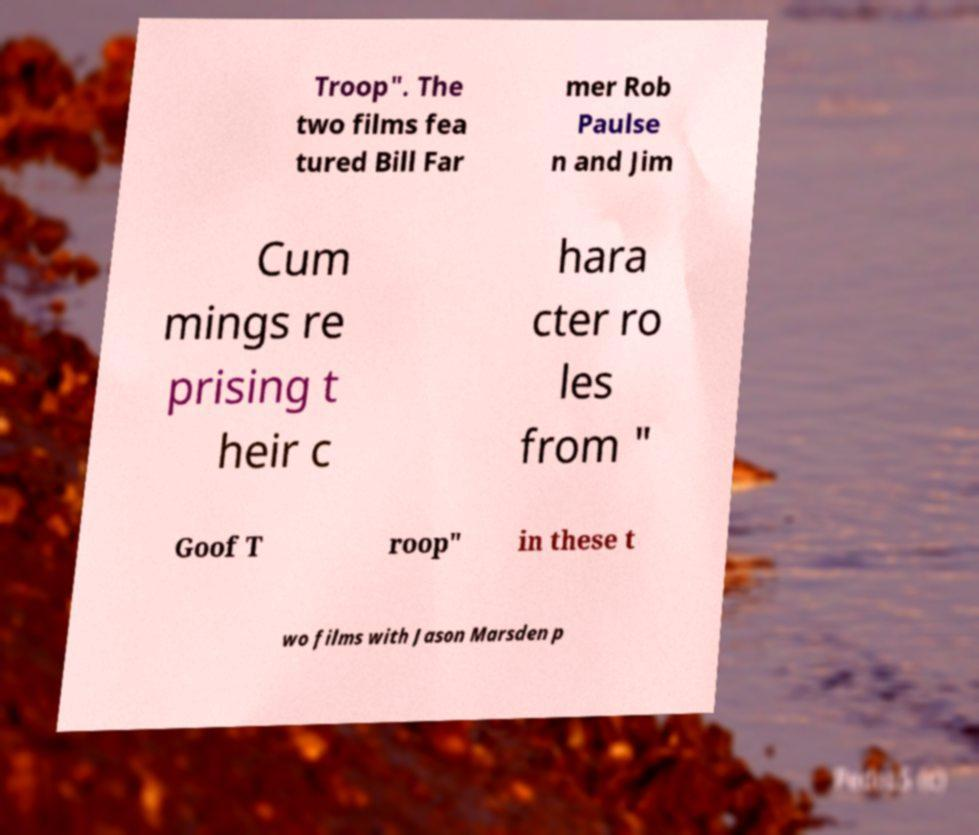I need the written content from this picture converted into text. Can you do that? Troop". The two films fea tured Bill Far mer Rob Paulse n and Jim Cum mings re prising t heir c hara cter ro les from " Goof T roop" in these t wo films with Jason Marsden p 